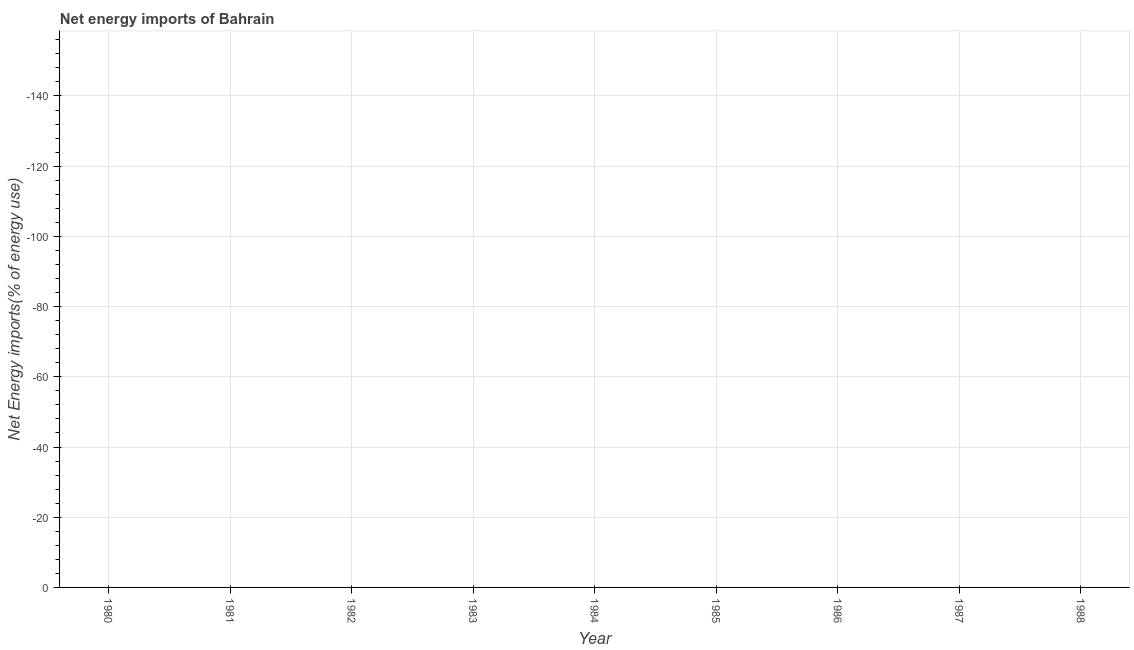Across all years, what is the minimum energy imports?
Keep it short and to the point. 0. What is the average energy imports per year?
Provide a succinct answer. 0. In how many years, is the energy imports greater than -12 %?
Your answer should be compact. 0. What is the difference between two consecutive major ticks on the Y-axis?
Make the answer very short. 20. Are the values on the major ticks of Y-axis written in scientific E-notation?
Ensure brevity in your answer.  No. Does the graph contain any zero values?
Provide a short and direct response. Yes. Does the graph contain grids?
Offer a terse response. Yes. What is the title of the graph?
Provide a short and direct response. Net energy imports of Bahrain. What is the label or title of the X-axis?
Make the answer very short. Year. What is the label or title of the Y-axis?
Ensure brevity in your answer.  Net Energy imports(% of energy use). What is the Net Energy imports(% of energy use) of 1980?
Your answer should be compact. 0. What is the Net Energy imports(% of energy use) of 1982?
Keep it short and to the point. 0. What is the Net Energy imports(% of energy use) in 1983?
Your answer should be compact. 0. What is the Net Energy imports(% of energy use) of 1984?
Offer a terse response. 0. What is the Net Energy imports(% of energy use) of 1986?
Your response must be concise. 0. What is the Net Energy imports(% of energy use) of 1987?
Offer a terse response. 0. 